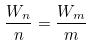<formula> <loc_0><loc_0><loc_500><loc_500>\frac { W _ { n } } { n } = \frac { W _ { m } } { m }</formula> 